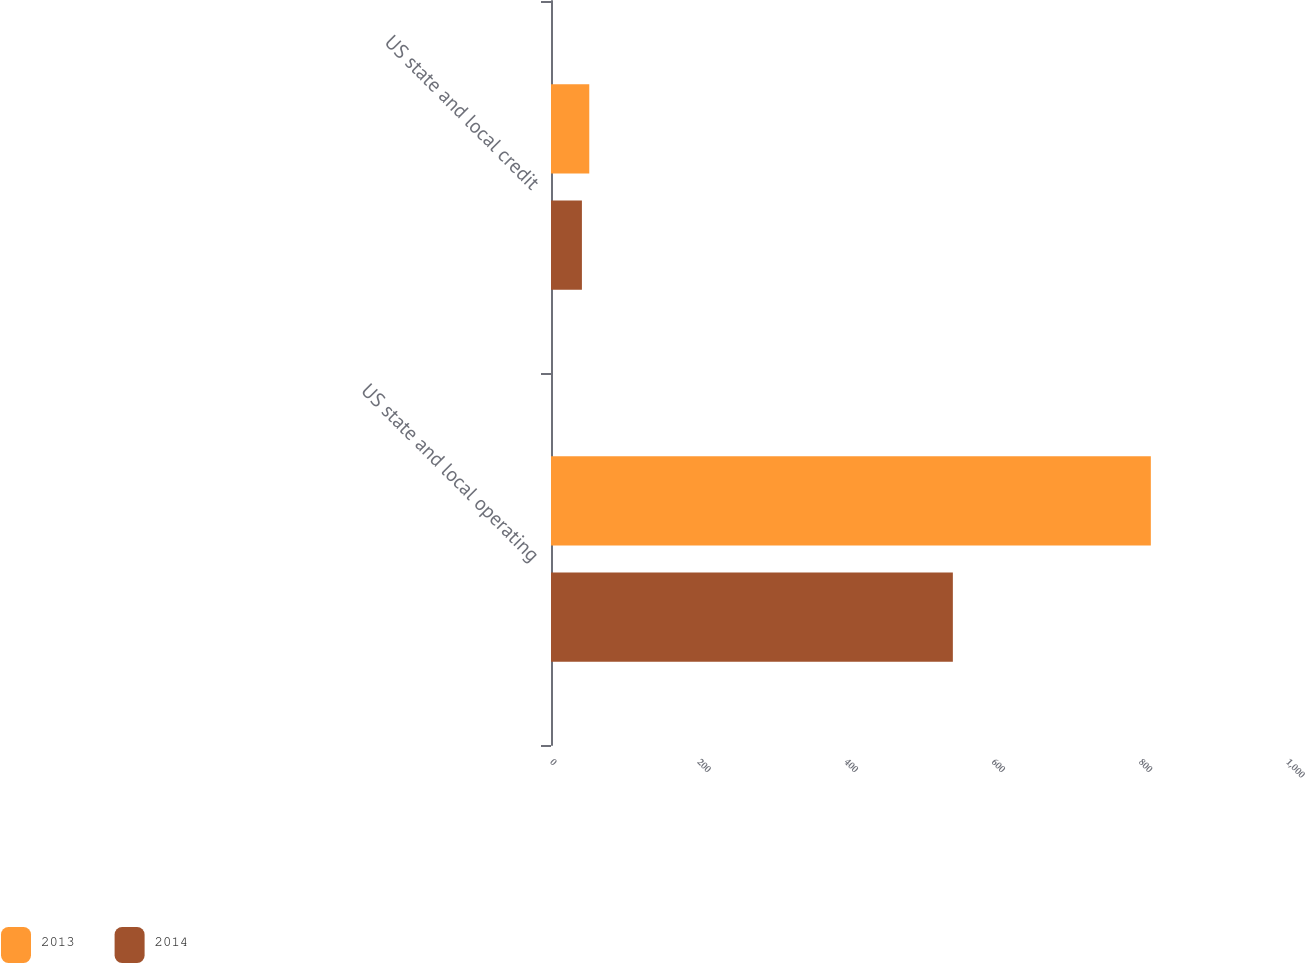<chart> <loc_0><loc_0><loc_500><loc_500><stacked_bar_chart><ecel><fcel>US state and local operating<fcel>US state and local credit<nl><fcel>2013<fcel>815<fcel>52<nl><fcel>2014<fcel>546<fcel>42<nl></chart> 